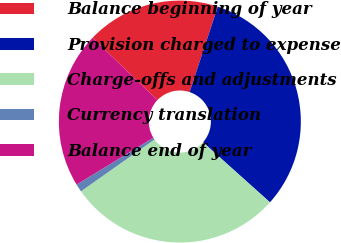<chart> <loc_0><loc_0><loc_500><loc_500><pie_chart><fcel>Balance beginning of year<fcel>Provision charged to expense<fcel>Charge-offs and adjustments<fcel>Currency translation<fcel>Balance end of year<nl><fcel>17.92%<fcel>31.55%<fcel>28.59%<fcel>1.06%<fcel>20.88%<nl></chart> 